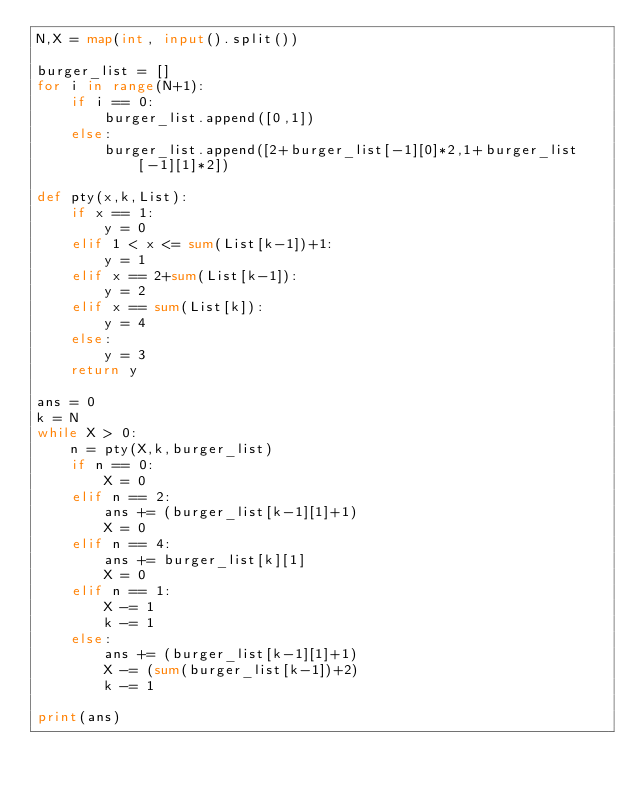<code> <loc_0><loc_0><loc_500><loc_500><_Python_>N,X = map(int, input().split())

burger_list = []
for i in range(N+1):
    if i == 0:
        burger_list.append([0,1])
    else:
        burger_list.append([2+burger_list[-1][0]*2,1+burger_list[-1][1]*2])

def pty(x,k,List):
    if x == 1:
        y = 0
    elif 1 < x <= sum(List[k-1])+1:
        y = 1
    elif x == 2+sum(List[k-1]):
        y = 2
    elif x == sum(List[k]):
        y = 4
    else:
        y = 3
    return y
        
ans = 0
k = N
while X > 0:
    n = pty(X,k,burger_list)
    if n == 0:
        X = 0
    elif n == 2:
        ans += (burger_list[k-1][1]+1)
        X = 0
    elif n == 4:
        ans += burger_list[k][1]
        X = 0
    elif n == 1:
        X -= 1
        k -= 1
    else:
        ans += (burger_list[k-1][1]+1)
        X -= (sum(burger_list[k-1])+2)
        k -= 1
        
print(ans)</code> 